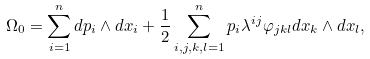<formula> <loc_0><loc_0><loc_500><loc_500>\Omega _ { 0 } = \sum _ { i = 1 } ^ { n } d p _ { i } \wedge d x _ { i } + \frac { 1 } { 2 } \sum _ { i , j , k , l = 1 } ^ { n } p _ { i } \lambda ^ { i j } \varphi _ { j k l } d x _ { k } \wedge d x _ { l } ,</formula> 